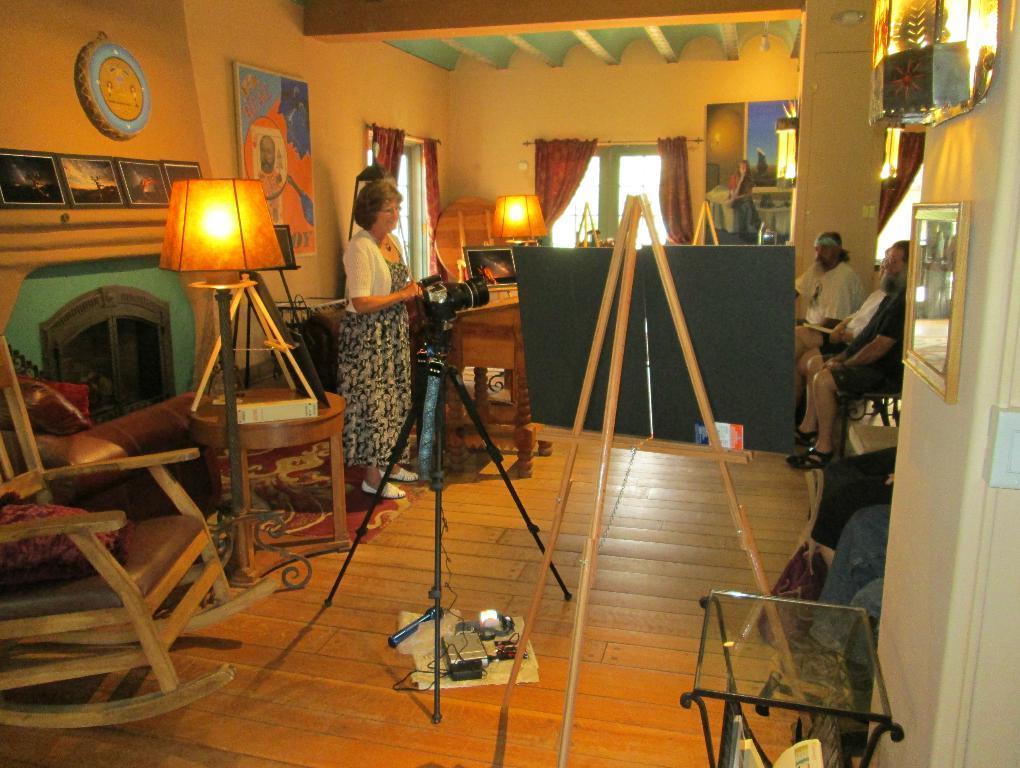Please provide a concise description of this image. In the image we can see there is a person who is standing and in front of her there is a camera with a stand and on the other side there are people who are sitting and on the wall there is a poster. 